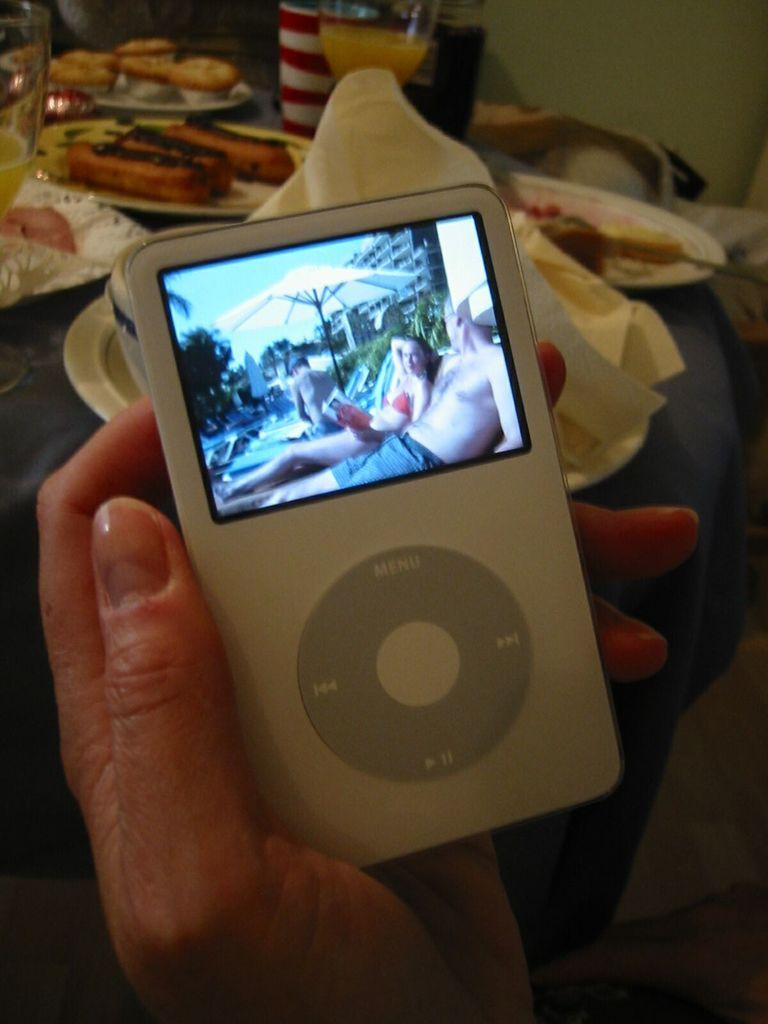Who is present in the image? There is a person in the image. What is the person holding in the image? The person is holding an electronic device. What is on the table in front of the person? There are plates with food and glasses with drinks in front of the person. On what surface are the plates and glasses placed? The plates and glasses are on a surface. What direction is the chain moving in the image? There is no chain present in the image. 